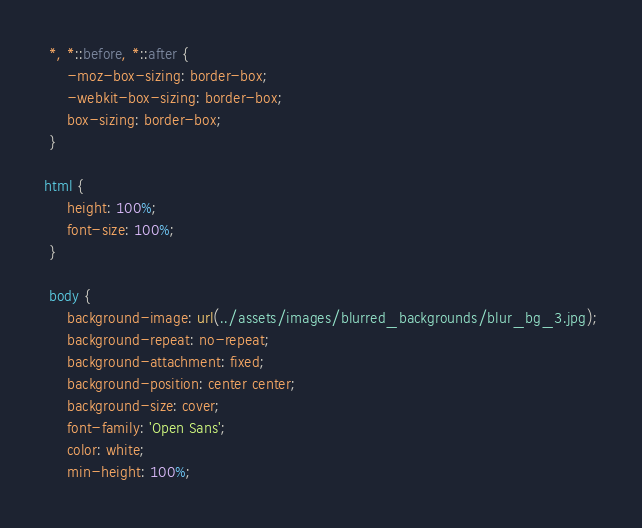Convert code to text. <code><loc_0><loc_0><loc_500><loc_500><_CSS_> *, *::before, *::after {
     -moz-box-sizing: border-box;
     -webkit-box-sizing: border-box;
     box-sizing: border-box;
 }

html {
     height: 100%;
     font-size: 100%;
 }

 body {
     background-image: url(../assets/images/blurred_backgrounds/blur_bg_3.jpg);
     background-repeat: no-repeat;
     background-attachment: fixed;
     background-position: center center;
     background-size: cover;
     font-family: 'Open Sans';
     color: white;
     min-height: 100%;</code> 